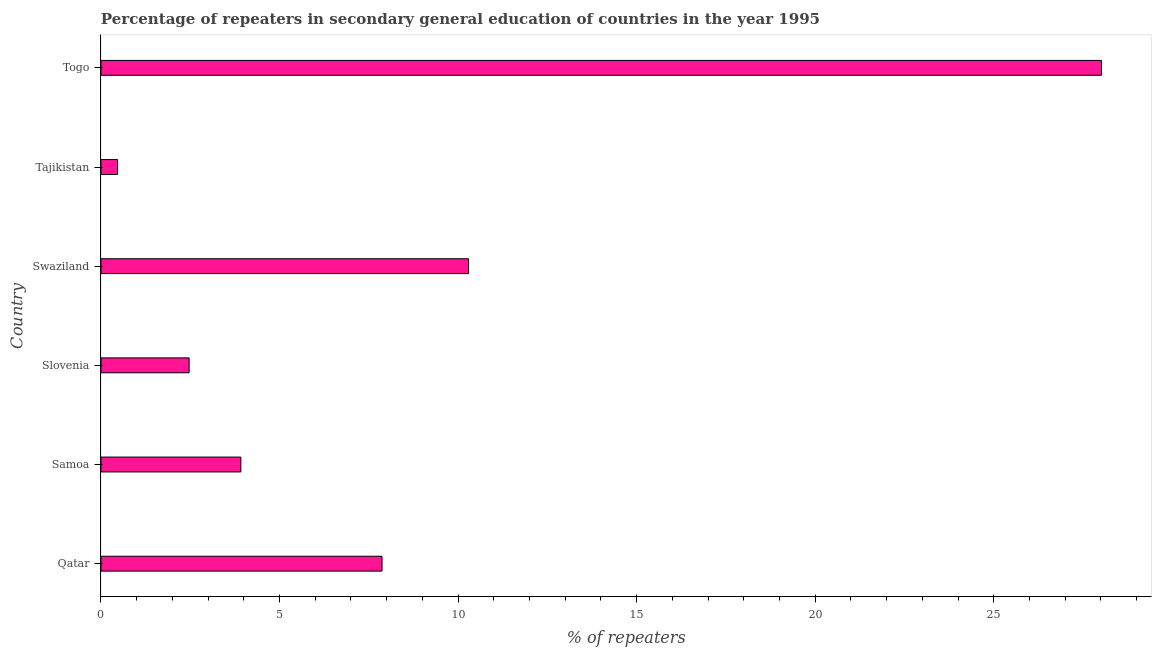Does the graph contain any zero values?
Provide a short and direct response. No. Does the graph contain grids?
Keep it short and to the point. No. What is the title of the graph?
Give a very brief answer. Percentage of repeaters in secondary general education of countries in the year 1995. What is the label or title of the X-axis?
Your answer should be very brief. % of repeaters. What is the percentage of repeaters in Slovenia?
Ensure brevity in your answer.  2.47. Across all countries, what is the maximum percentage of repeaters?
Ensure brevity in your answer.  28.02. Across all countries, what is the minimum percentage of repeaters?
Your response must be concise. 0.46. In which country was the percentage of repeaters maximum?
Offer a very short reply. Togo. In which country was the percentage of repeaters minimum?
Offer a terse response. Tajikistan. What is the sum of the percentage of repeaters?
Offer a terse response. 53.03. What is the difference between the percentage of repeaters in Samoa and Tajikistan?
Keep it short and to the point. 3.45. What is the average percentage of repeaters per country?
Offer a very short reply. 8.84. What is the median percentage of repeaters?
Ensure brevity in your answer.  5.89. What is the ratio of the percentage of repeaters in Qatar to that in Swaziland?
Your answer should be compact. 0.77. Is the difference between the percentage of repeaters in Qatar and Togo greater than the difference between any two countries?
Give a very brief answer. No. What is the difference between the highest and the second highest percentage of repeaters?
Provide a succinct answer. 17.72. Is the sum of the percentage of repeaters in Qatar and Swaziland greater than the maximum percentage of repeaters across all countries?
Your response must be concise. No. What is the difference between the highest and the lowest percentage of repeaters?
Keep it short and to the point. 27.55. How many bars are there?
Ensure brevity in your answer.  6. Are all the bars in the graph horizontal?
Offer a very short reply. Yes. How many countries are there in the graph?
Provide a succinct answer. 6. What is the % of repeaters in Qatar?
Make the answer very short. 7.87. What is the % of repeaters of Samoa?
Your answer should be very brief. 3.92. What is the % of repeaters of Slovenia?
Your answer should be compact. 2.47. What is the % of repeaters in Swaziland?
Offer a very short reply. 10.29. What is the % of repeaters in Tajikistan?
Make the answer very short. 0.46. What is the % of repeaters in Togo?
Offer a terse response. 28.02. What is the difference between the % of repeaters in Qatar and Samoa?
Keep it short and to the point. 3.95. What is the difference between the % of repeaters in Qatar and Slovenia?
Your answer should be compact. 5.4. What is the difference between the % of repeaters in Qatar and Swaziland?
Make the answer very short. -2.42. What is the difference between the % of repeaters in Qatar and Tajikistan?
Ensure brevity in your answer.  7.41. What is the difference between the % of repeaters in Qatar and Togo?
Offer a terse response. -20.15. What is the difference between the % of repeaters in Samoa and Slovenia?
Provide a short and direct response. 1.45. What is the difference between the % of repeaters in Samoa and Swaziland?
Make the answer very short. -6.38. What is the difference between the % of repeaters in Samoa and Tajikistan?
Make the answer very short. 3.45. What is the difference between the % of repeaters in Samoa and Togo?
Provide a short and direct response. -24.1. What is the difference between the % of repeaters in Slovenia and Swaziland?
Provide a short and direct response. -7.82. What is the difference between the % of repeaters in Slovenia and Tajikistan?
Ensure brevity in your answer.  2. What is the difference between the % of repeaters in Slovenia and Togo?
Your answer should be compact. -25.55. What is the difference between the % of repeaters in Swaziland and Tajikistan?
Ensure brevity in your answer.  9.83. What is the difference between the % of repeaters in Swaziland and Togo?
Ensure brevity in your answer.  -17.72. What is the difference between the % of repeaters in Tajikistan and Togo?
Offer a terse response. -27.55. What is the ratio of the % of repeaters in Qatar to that in Samoa?
Give a very brief answer. 2.01. What is the ratio of the % of repeaters in Qatar to that in Slovenia?
Your answer should be very brief. 3.19. What is the ratio of the % of repeaters in Qatar to that in Swaziland?
Your answer should be compact. 0.77. What is the ratio of the % of repeaters in Qatar to that in Tajikistan?
Keep it short and to the point. 16.95. What is the ratio of the % of repeaters in Qatar to that in Togo?
Your answer should be compact. 0.28. What is the ratio of the % of repeaters in Samoa to that in Slovenia?
Your response must be concise. 1.59. What is the ratio of the % of repeaters in Samoa to that in Swaziland?
Offer a terse response. 0.38. What is the ratio of the % of repeaters in Samoa to that in Tajikistan?
Ensure brevity in your answer.  8.44. What is the ratio of the % of repeaters in Samoa to that in Togo?
Give a very brief answer. 0.14. What is the ratio of the % of repeaters in Slovenia to that in Swaziland?
Make the answer very short. 0.24. What is the ratio of the % of repeaters in Slovenia to that in Tajikistan?
Give a very brief answer. 5.32. What is the ratio of the % of repeaters in Slovenia to that in Togo?
Make the answer very short. 0.09. What is the ratio of the % of repeaters in Swaziland to that in Tajikistan?
Ensure brevity in your answer.  22.17. What is the ratio of the % of repeaters in Swaziland to that in Togo?
Provide a short and direct response. 0.37. What is the ratio of the % of repeaters in Tajikistan to that in Togo?
Offer a terse response. 0.02. 